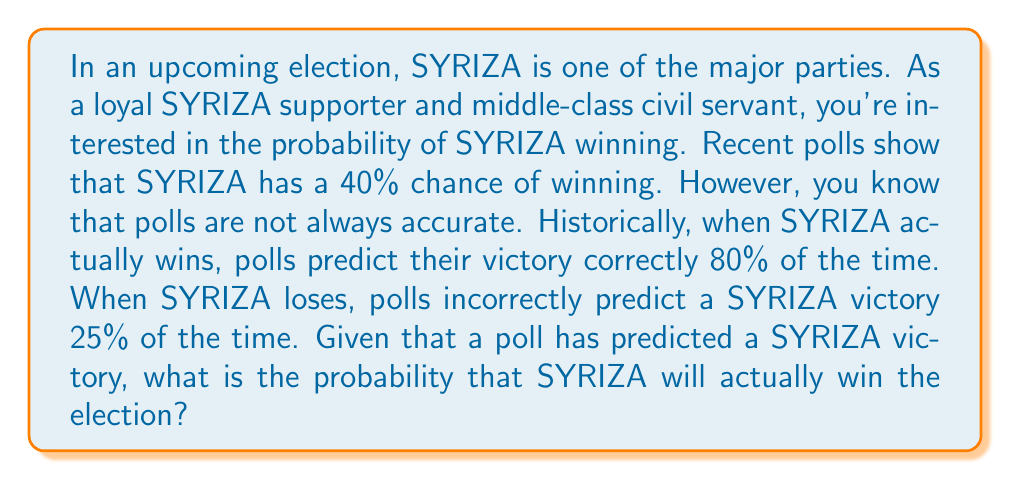Show me your answer to this math problem. To solve this problem, we'll use Bayes' theorem. Let's define our events:

A: SYRIZA actually wins the election
B: The poll predicts a SYRIZA victory

We're given the following probabilities:

$P(A) = 0.40$ (prior probability of SYRIZA winning)
$P(B|A) = 0.80$ (probability of poll predicting victory given SYRIZA actually wins)
$P(B|\neg A) = 0.25$ (probability of poll predicting victory given SYRIZA actually loses)

We want to find $P(A|B)$, the probability that SYRIZA actually wins given that the poll predicts their victory.

Bayes' theorem states:

$$P(A|B) = \frac{P(B|A) \cdot P(A)}{P(B)}$$

To find $P(B)$, we use the law of total probability:

$$P(B) = P(B|A) \cdot P(A) + P(B|\neg A) \cdot P(\neg A)$$

$P(\neg A) = 1 - P(A) = 1 - 0.40 = 0.60$

Now we can calculate $P(B)$:

$$P(B) = 0.80 \cdot 0.40 + 0.25 \cdot 0.60 = 0.32 + 0.15 = 0.47$$

Plugging everything into Bayes' theorem:

$$P(A|B) = \frac{0.80 \cdot 0.40}{0.47} \approx 0.6809$$
Answer: The probability that SYRIZA will actually win the election, given that a poll has predicted their victory, is approximately 0.6809 or 68.09%. 